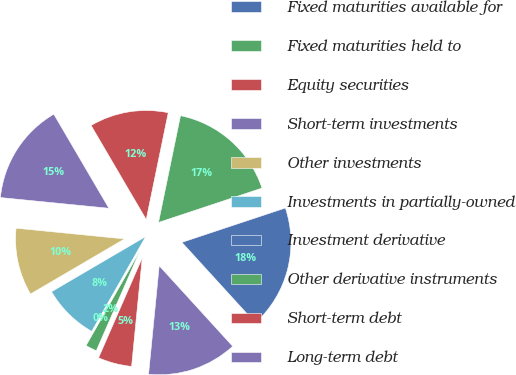Convert chart. <chart><loc_0><loc_0><loc_500><loc_500><pie_chart><fcel>Fixed maturities available for<fcel>Fixed maturities held to<fcel>Equity securities<fcel>Short-term investments<fcel>Other investments<fcel>Investments in partially-owned<fcel>Investment derivative<fcel>Other derivative instruments<fcel>Short-term debt<fcel>Long-term debt<nl><fcel>18.33%<fcel>16.66%<fcel>11.67%<fcel>15.0%<fcel>10.0%<fcel>8.33%<fcel>0.01%<fcel>1.67%<fcel>5.0%<fcel>13.33%<nl></chart> 